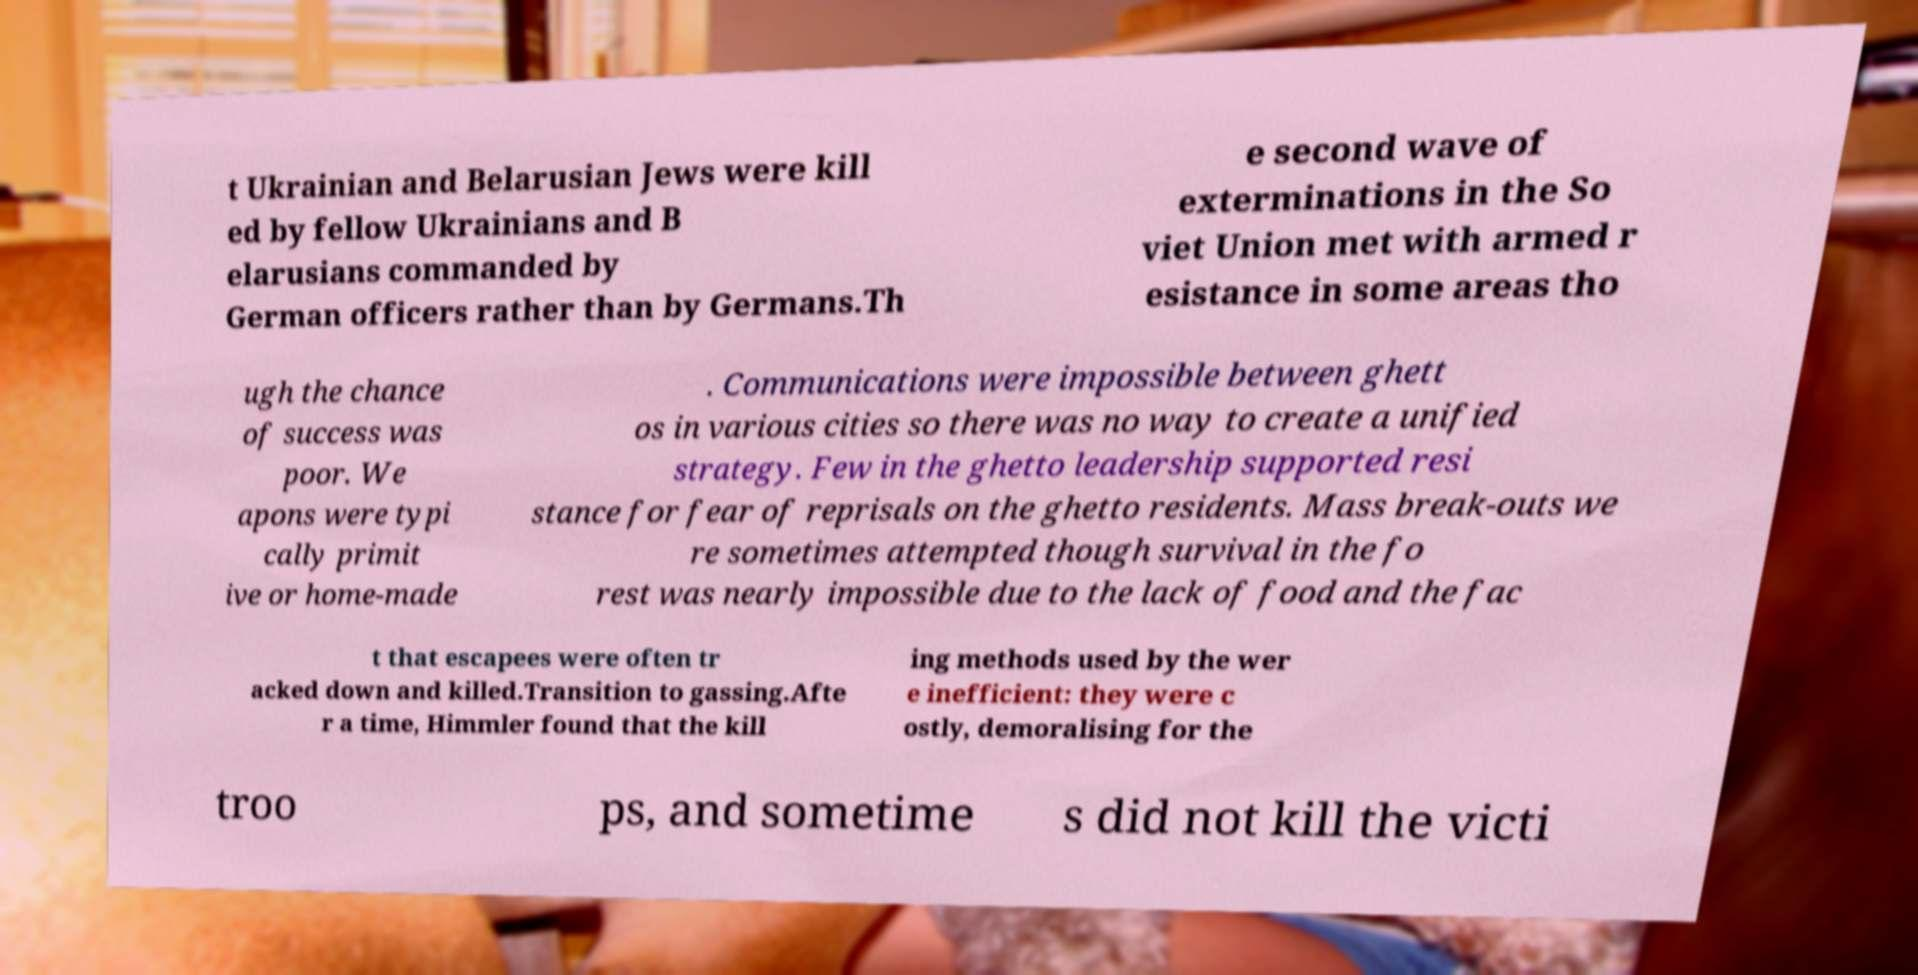What messages or text are displayed in this image? I need them in a readable, typed format. t Ukrainian and Belarusian Jews were kill ed by fellow Ukrainians and B elarusians commanded by German officers rather than by Germans.Th e second wave of exterminations in the So viet Union met with armed r esistance in some areas tho ugh the chance of success was poor. We apons were typi cally primit ive or home-made . Communications were impossible between ghett os in various cities so there was no way to create a unified strategy. Few in the ghetto leadership supported resi stance for fear of reprisals on the ghetto residents. Mass break-outs we re sometimes attempted though survival in the fo rest was nearly impossible due to the lack of food and the fac t that escapees were often tr acked down and killed.Transition to gassing.Afte r a time, Himmler found that the kill ing methods used by the wer e inefficient: they were c ostly, demoralising for the troo ps, and sometime s did not kill the victi 